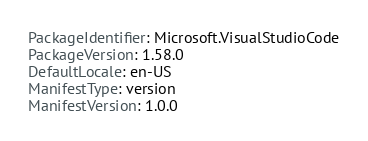Convert code to text. <code><loc_0><loc_0><loc_500><loc_500><_YAML_>PackageIdentifier: Microsoft.VisualStudioCode
PackageVersion: 1.58.0
DefaultLocale: en-US
ManifestType: version
ManifestVersion: 1.0.0
</code> 